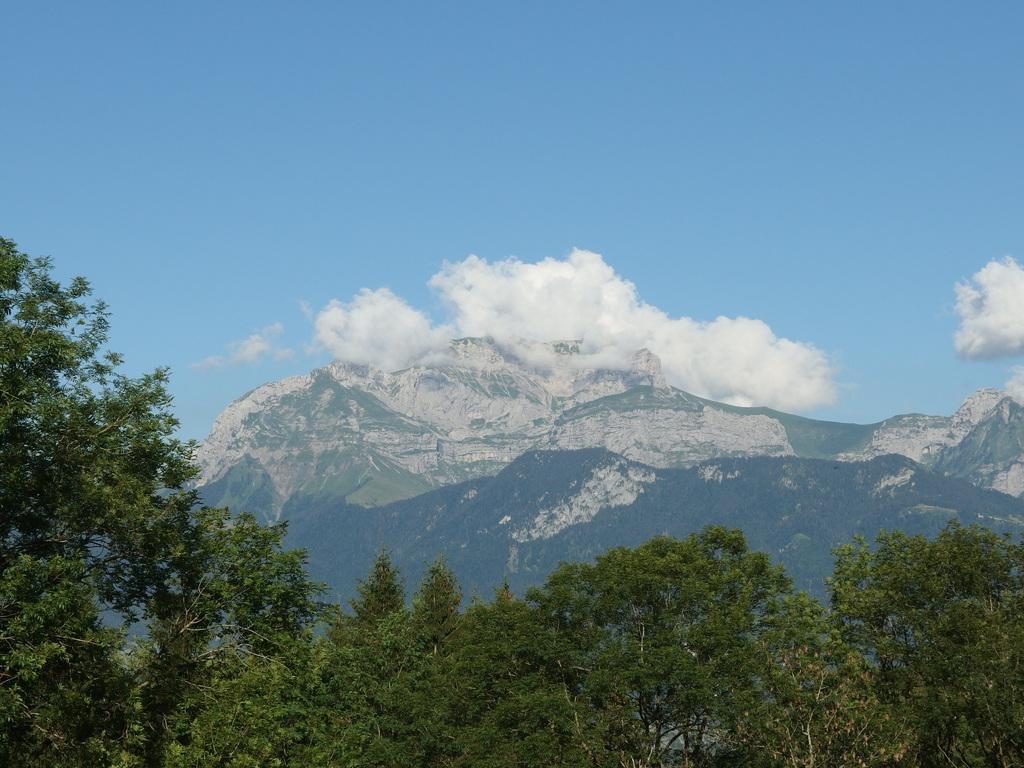Can you describe this image briefly? This picture is clicked outside the city. In the foreground we can see the trees. In the center there are some hills. In the background we can see the sky with the clouds. 